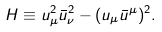Convert formula to latex. <formula><loc_0><loc_0><loc_500><loc_500>H \equiv u _ { \mu } ^ { 2 } \bar { u } _ { \nu } ^ { 2 } - ( u _ { \mu } \bar { u } ^ { \mu } ) ^ { 2 } .</formula> 